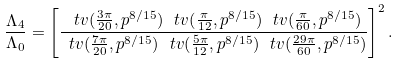Convert formula to latex. <formula><loc_0><loc_0><loc_500><loc_500>\frac { \Lambda _ { 4 } } { \Lambda _ { 0 } } = \left [ \frac { \ t v ( \frac { 3 \pi } { 2 0 } , p ^ { 8 / 1 5 } ) \, \ t v ( \frac { \pi } { 1 2 } , p ^ { 8 / 1 5 } ) \, \ t v ( \frac { \pi } { 6 0 } , p ^ { 8 / 1 5 } ) } { \ t v ( \frac { 7 \pi } { 2 0 } , p ^ { 8 / 1 5 } ) \, \ t v ( \frac { 5 \pi } { 1 2 } , p ^ { 8 / 1 5 } ) \, \ t v ( \frac { 2 9 \pi } { 6 0 } , p ^ { 8 / 1 5 } ) } \right ] ^ { 2 } .</formula> 